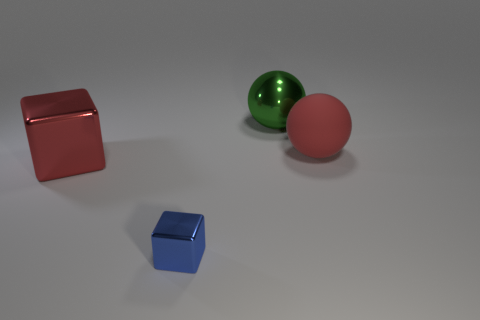Add 2 cylinders. How many objects exist? 6 Add 2 tiny blue metallic objects. How many tiny blue metallic objects exist? 3 Subtract 0 cyan cylinders. How many objects are left? 4 Subtract all green spheres. Subtract all large balls. How many objects are left? 1 Add 2 red things. How many red things are left? 4 